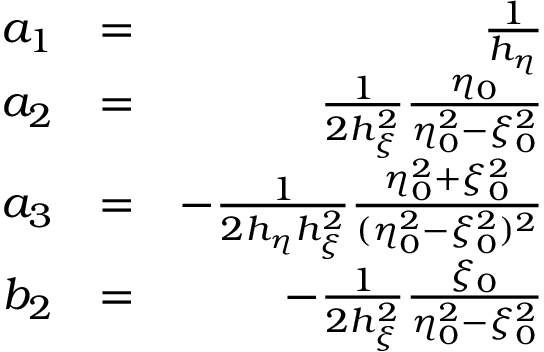Convert formula to latex. <formula><loc_0><loc_0><loc_500><loc_500>\begin{array} { r l r } { a _ { 1 } } & { = } & { \frac { 1 } { h _ { \eta } } } \\ { a _ { 2 } } & { = } & { \frac { 1 } { 2 h _ { \xi } ^ { 2 } } \frac { \eta _ { 0 } } { \eta _ { 0 } ^ { 2 } - \xi _ { 0 } ^ { 2 } } } \\ { a _ { 3 } } & { = } & { - \frac { 1 } { 2 h _ { \eta } h _ { \xi } ^ { 2 } } \frac { \eta _ { 0 } ^ { 2 } + \xi _ { 0 } ^ { 2 } } { ( \eta _ { 0 } ^ { 2 } - \xi _ { 0 } ^ { 2 } ) ^ { 2 } } } \\ { b _ { 2 } } & { = } & { - \frac { 1 } { 2 h _ { \xi } ^ { 2 } } \frac { \xi _ { 0 } } { \eta _ { 0 } ^ { 2 } - \xi _ { 0 } ^ { 2 } } } \end{array}</formula> 